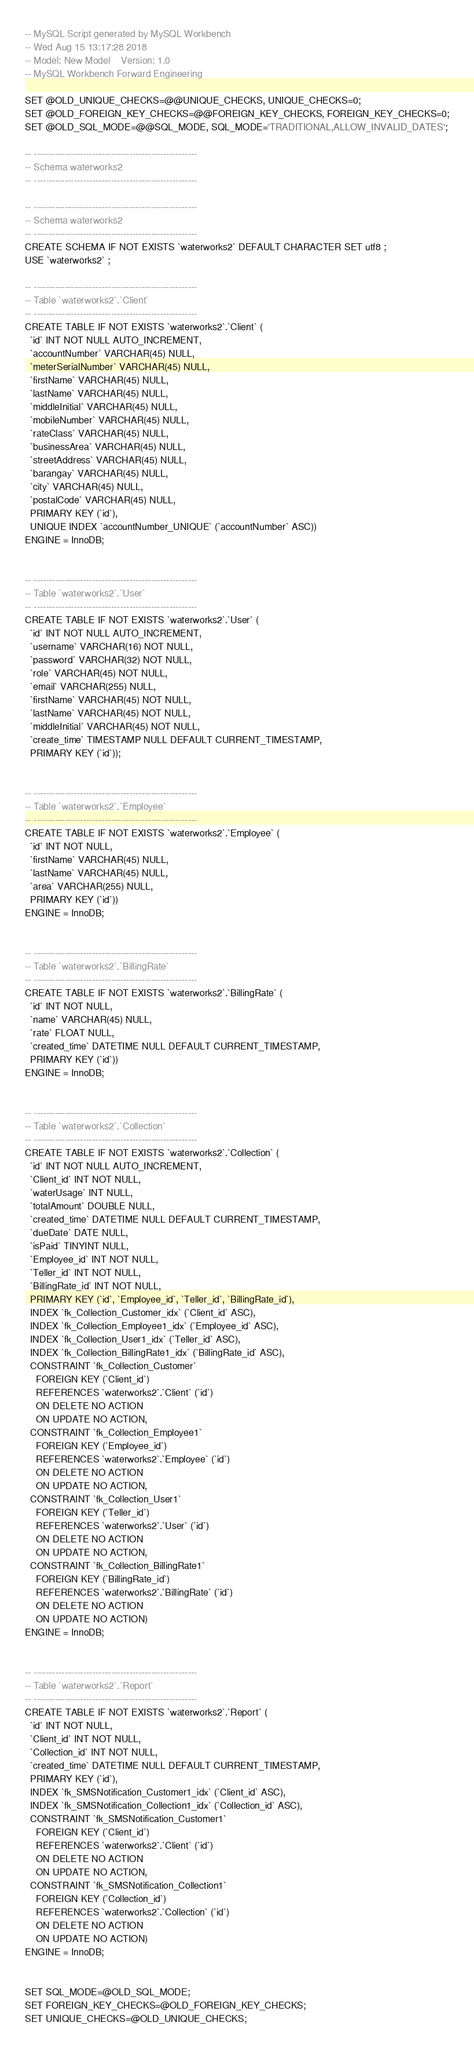<code> <loc_0><loc_0><loc_500><loc_500><_SQL_>-- MySQL Script generated by MySQL Workbench
-- Wed Aug 15 13:17:28 2018
-- Model: New Model    Version: 1.0
-- MySQL Workbench Forward Engineering

SET @OLD_UNIQUE_CHECKS=@@UNIQUE_CHECKS, UNIQUE_CHECKS=0;
SET @OLD_FOREIGN_KEY_CHECKS=@@FOREIGN_KEY_CHECKS, FOREIGN_KEY_CHECKS=0;
SET @OLD_SQL_MODE=@@SQL_MODE, SQL_MODE='TRADITIONAL,ALLOW_INVALID_DATES';

-- -----------------------------------------------------
-- Schema waterworks2
-- -----------------------------------------------------

-- -----------------------------------------------------
-- Schema waterworks2
-- -----------------------------------------------------
CREATE SCHEMA IF NOT EXISTS `waterworks2` DEFAULT CHARACTER SET utf8 ;
USE `waterworks2` ;

-- -----------------------------------------------------
-- Table `waterworks2`.`Client`
-- -----------------------------------------------------
CREATE TABLE IF NOT EXISTS `waterworks2`.`Client` (
  `id` INT NOT NULL AUTO_INCREMENT,
  `accountNumber` VARCHAR(45) NULL,
  `meterSerialNumber` VARCHAR(45) NULL,
  `firstName` VARCHAR(45) NULL,
  `lastName` VARCHAR(45) NULL,
  `middleInitial` VARCHAR(45) NULL,
  `mobileNumber` VARCHAR(45) NULL,
  `rateClass` VARCHAR(45) NULL,
  `businessArea` VARCHAR(45) NULL,
  `streetAddress` VARCHAR(45) NULL,
  `barangay` VARCHAR(45) NULL,
  `city` VARCHAR(45) NULL,
  `postalCode` VARCHAR(45) NULL,
  PRIMARY KEY (`id`),
  UNIQUE INDEX `accountNumber_UNIQUE` (`accountNumber` ASC))
ENGINE = InnoDB;


-- -----------------------------------------------------
-- Table `waterworks2`.`User`
-- -----------------------------------------------------
CREATE TABLE IF NOT EXISTS `waterworks2`.`User` (
  `id` INT NOT NULL AUTO_INCREMENT,
  `username` VARCHAR(16) NOT NULL,
  `password` VARCHAR(32) NOT NULL,
  `role` VARCHAR(45) NOT NULL,
  `email` VARCHAR(255) NULL,
  `firstName` VARCHAR(45) NOT NULL,
  `lastName` VARCHAR(45) NOT NULL,
  `middleInitial` VARCHAR(45) NOT NULL,
  `create_time` TIMESTAMP NULL DEFAULT CURRENT_TIMESTAMP,
  PRIMARY KEY (`id`));


-- -----------------------------------------------------
-- Table `waterworks2`.`Employee`
-- -----------------------------------------------------
CREATE TABLE IF NOT EXISTS `waterworks2`.`Employee` (
  `id` INT NOT NULL,
  `firstName` VARCHAR(45) NULL,
  `lastName` VARCHAR(45) NULL,
  `area` VARCHAR(255) NULL,
  PRIMARY KEY (`id`))
ENGINE = InnoDB;


-- -----------------------------------------------------
-- Table `waterworks2`.`BillingRate`
-- -----------------------------------------------------
CREATE TABLE IF NOT EXISTS `waterworks2`.`BillingRate` (
  `id` INT NOT NULL,
  `name` VARCHAR(45) NULL,
  `rate` FLOAT NULL,
  `created_time` DATETIME NULL DEFAULT CURRENT_TIMESTAMP,
  PRIMARY KEY (`id`))
ENGINE = InnoDB;


-- -----------------------------------------------------
-- Table `waterworks2`.`Collection`
-- -----------------------------------------------------
CREATE TABLE IF NOT EXISTS `waterworks2`.`Collection` (
  `id` INT NOT NULL AUTO_INCREMENT,
  `Client_id` INT NOT NULL,
  `waterUsage` INT NULL,
  `totalAmount` DOUBLE NULL,
  `created_time` DATETIME NULL DEFAULT CURRENT_TIMESTAMP,
  `dueDate` DATE NULL,
  `isPaid` TINYINT NULL,
  `Employee_id` INT NOT NULL,
  `Teller_id` INT NOT NULL,
  `BillingRate_id` INT NOT NULL,
  PRIMARY KEY (`id`, `Employee_id`, `Teller_id`, `BillingRate_id`),
  INDEX `fk_Collection_Customer_idx` (`Client_id` ASC),
  INDEX `fk_Collection_Employee1_idx` (`Employee_id` ASC),
  INDEX `fk_Collection_User1_idx` (`Teller_id` ASC),
  INDEX `fk_Collection_BillingRate1_idx` (`BillingRate_id` ASC),
  CONSTRAINT `fk_Collection_Customer`
    FOREIGN KEY (`Client_id`)
    REFERENCES `waterworks2`.`Client` (`id`)
    ON DELETE NO ACTION
    ON UPDATE NO ACTION,
  CONSTRAINT `fk_Collection_Employee1`
    FOREIGN KEY (`Employee_id`)
    REFERENCES `waterworks2`.`Employee` (`id`)
    ON DELETE NO ACTION
    ON UPDATE NO ACTION,
  CONSTRAINT `fk_Collection_User1`
    FOREIGN KEY (`Teller_id`)
    REFERENCES `waterworks2`.`User` (`id`)
    ON DELETE NO ACTION
    ON UPDATE NO ACTION,
  CONSTRAINT `fk_Collection_BillingRate1`
    FOREIGN KEY (`BillingRate_id`)
    REFERENCES `waterworks2`.`BillingRate` (`id`)
    ON DELETE NO ACTION
    ON UPDATE NO ACTION)
ENGINE = InnoDB;


-- -----------------------------------------------------
-- Table `waterworks2`.`Report`
-- -----------------------------------------------------
CREATE TABLE IF NOT EXISTS `waterworks2`.`Report` (
  `id` INT NOT NULL,
  `Client_id` INT NOT NULL,
  `Collection_id` INT NOT NULL,
  `created_time` DATETIME NULL DEFAULT CURRENT_TIMESTAMP,
  PRIMARY KEY (`id`),
  INDEX `fk_SMSNotification_Customer1_idx` (`Client_id` ASC),
  INDEX `fk_SMSNotification_Collection1_idx` (`Collection_id` ASC),
  CONSTRAINT `fk_SMSNotification_Customer1`
    FOREIGN KEY (`Client_id`)
    REFERENCES `waterworks2`.`Client` (`id`)
    ON DELETE NO ACTION
    ON UPDATE NO ACTION,
  CONSTRAINT `fk_SMSNotification_Collection1`
    FOREIGN KEY (`Collection_id`)
    REFERENCES `waterworks2`.`Collection` (`id`)
    ON DELETE NO ACTION
    ON UPDATE NO ACTION)
ENGINE = InnoDB;


SET SQL_MODE=@OLD_SQL_MODE;
SET FOREIGN_KEY_CHECKS=@OLD_FOREIGN_KEY_CHECKS;
SET UNIQUE_CHECKS=@OLD_UNIQUE_CHECKS;
</code> 